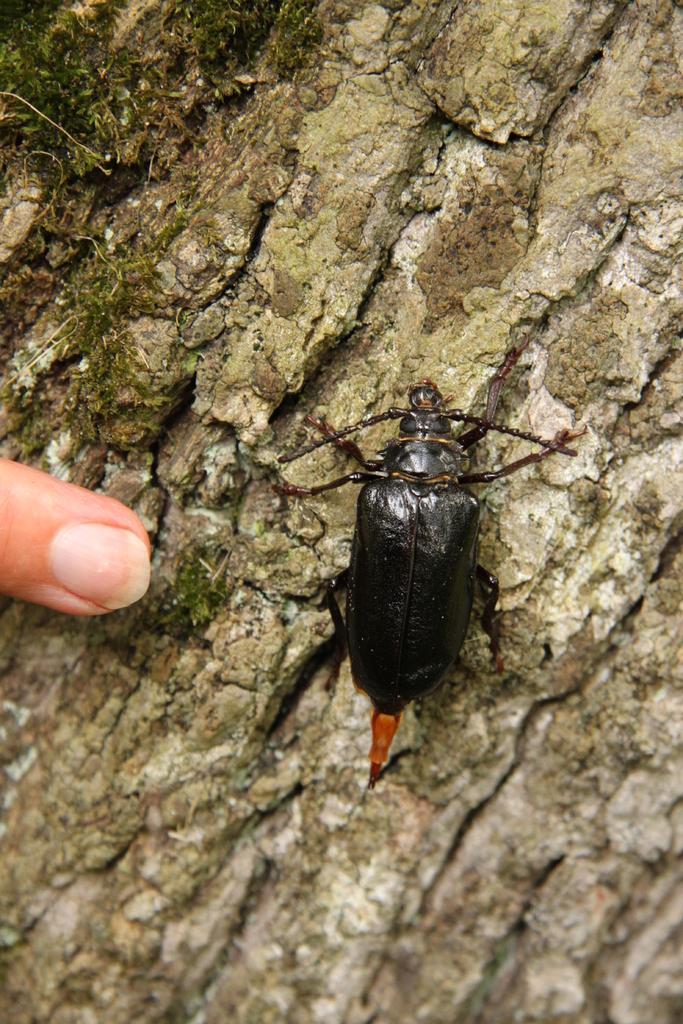Describe this image in one or two sentences. In this picture we can see an insect. 